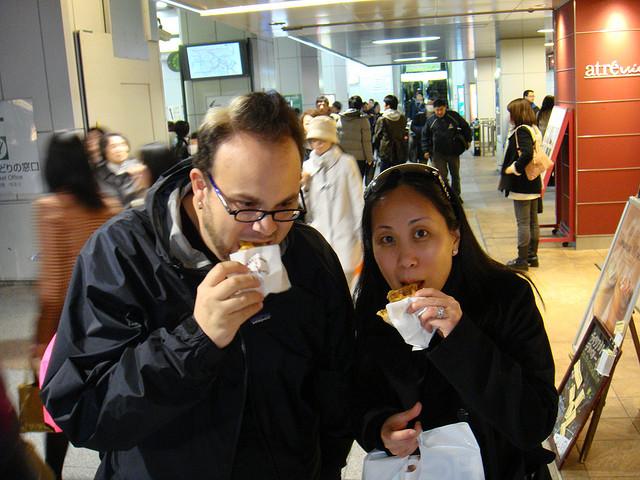Are they at an art gallery?
Short answer required. Yes. What are the people doing?
Give a very brief answer. Eating. What number is on the sign?
Give a very brief answer. 6. Is the woman wearing earrings?
Concise answer only. Yes. 